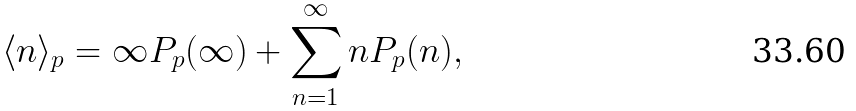<formula> <loc_0><loc_0><loc_500><loc_500>\langle n \rangle _ { p } = \infty P _ { p } ( \infty ) + \sum _ { n = 1 } ^ { \infty } n P _ { p } ( n ) ,</formula> 